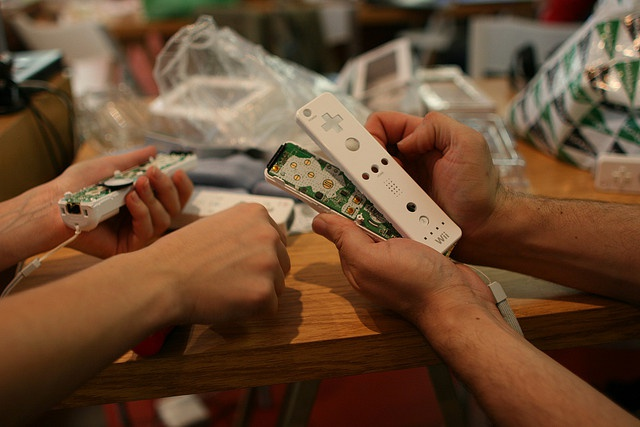Describe the objects in this image and their specific colors. I can see dining table in gray, black, and darkgray tones, people in gray, brown, maroon, and black tones, people in gray, brown, maroon, black, and salmon tones, remote in gray, tan, and black tones, and remote in gray, tan, and maroon tones in this image. 